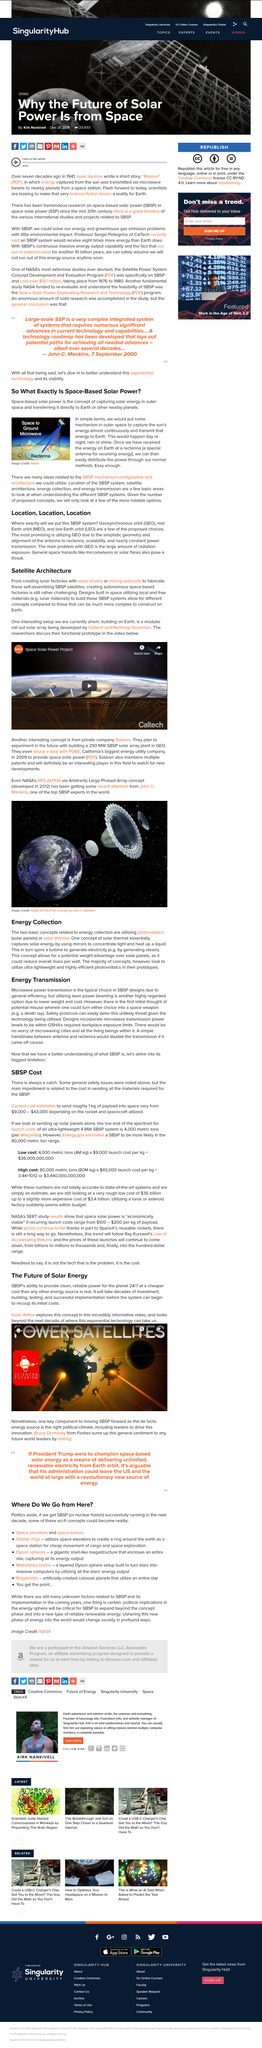Highlight a few significant elements in this photo. The GEO orbit is the most promising orbit for the SBSP system due to its simplistic geometry, alignment of the antenna to rectenna, scalability, and nearly constant power transmission, making it the ideal choice for harnessing the abundant and clean energy of space. Lunar materials are a local and free material available in space that can be used for various purposes, such as construction and resource utilization. The functional prototype discussed in the video is a modular roll-out solar array. I, [Name], declare that Space Based Solar Power (SBSP) has the ability to provide clean, reliable, power for the planet 24/7 at a cheaper cost than any other energy source. MEO stands for Mid Earth Orbit, which refers to a type of orbit located approximately 22,000 miles above the Earth's surface. This orbit is often used for communications satellites due to its location and the fact that it provides a clear line of sight to both the Earth's equator and the satellite's destination. 